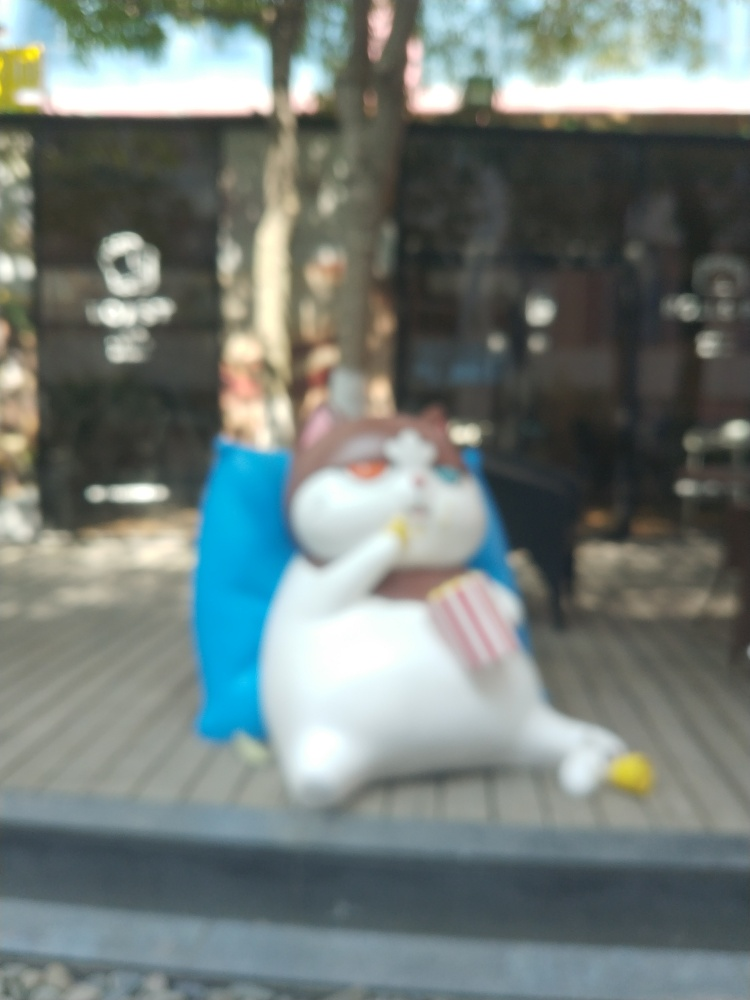Is this image suitable for professional use? Given the blurriness and lack of detail, this image would not typically meet the standards for professional use where clarity and sharp focus are important. What emotions does this image evoke? The subject's relaxed pose and the whimsical depiction of a cat-like figure may evoke feelings of playfulness, lightheartedness, and relaxation. 